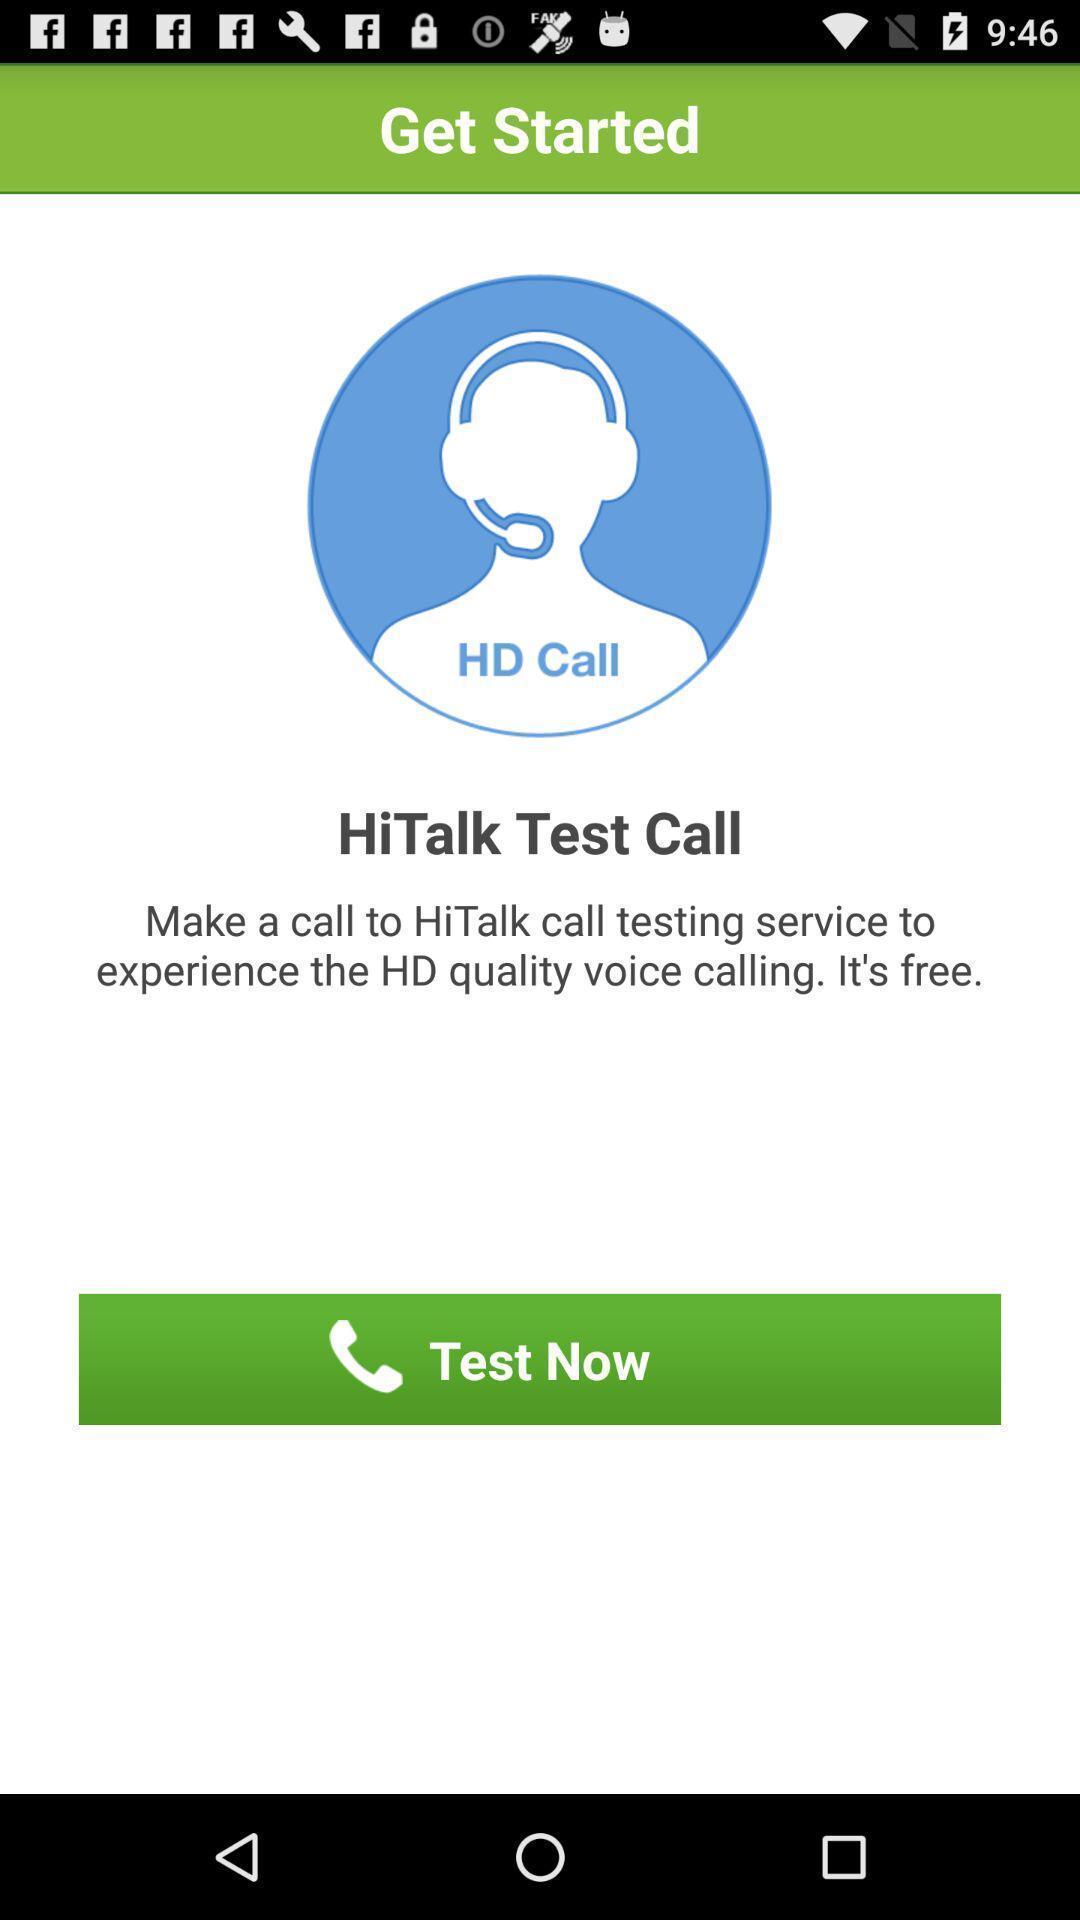Describe the key features of this screenshot. Welcome page for the call quality application. 